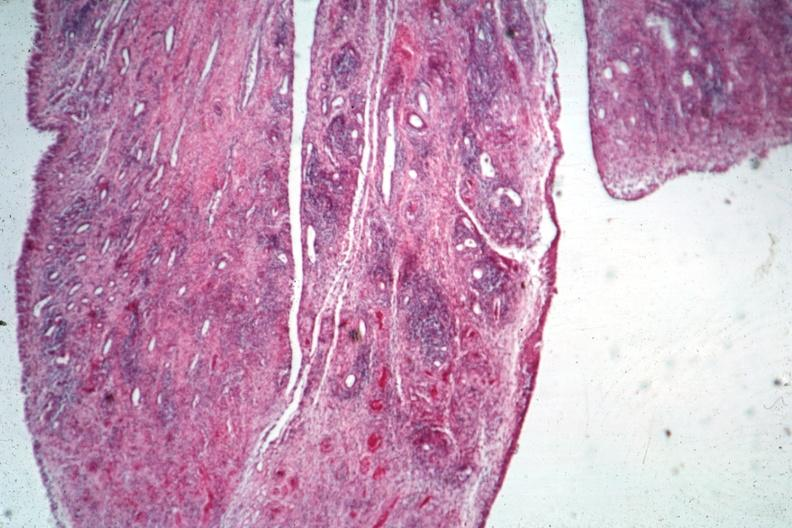does histoplasmosis show typical lesion?
Answer the question using a single word or phrase. No 